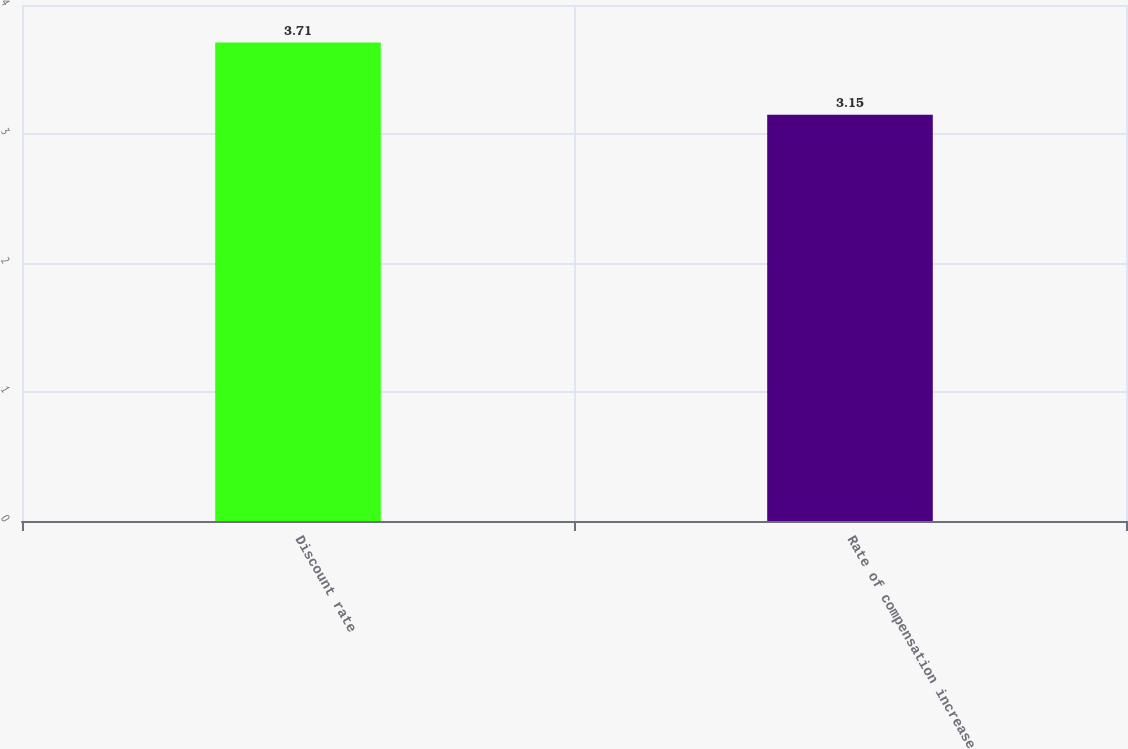Convert chart. <chart><loc_0><loc_0><loc_500><loc_500><bar_chart><fcel>Discount rate<fcel>Rate of compensation increase<nl><fcel>3.71<fcel>3.15<nl></chart> 